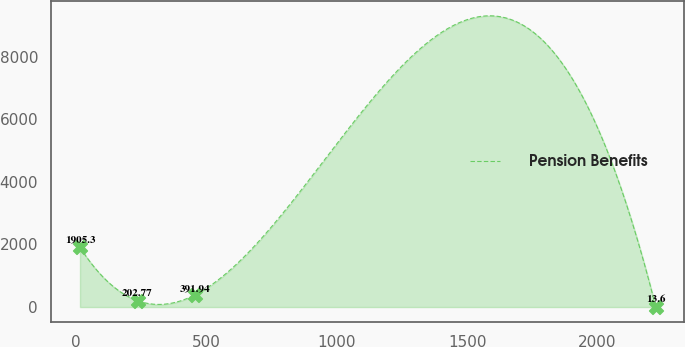Convert chart to OTSL. <chart><loc_0><loc_0><loc_500><loc_500><line_chart><ecel><fcel>Pension Benefits<nl><fcel>14.16<fcel>1905.3<nl><fcel>235.04<fcel>202.77<nl><fcel>455.92<fcel>391.94<nl><fcel>2222.92<fcel>13.6<nl></chart> 